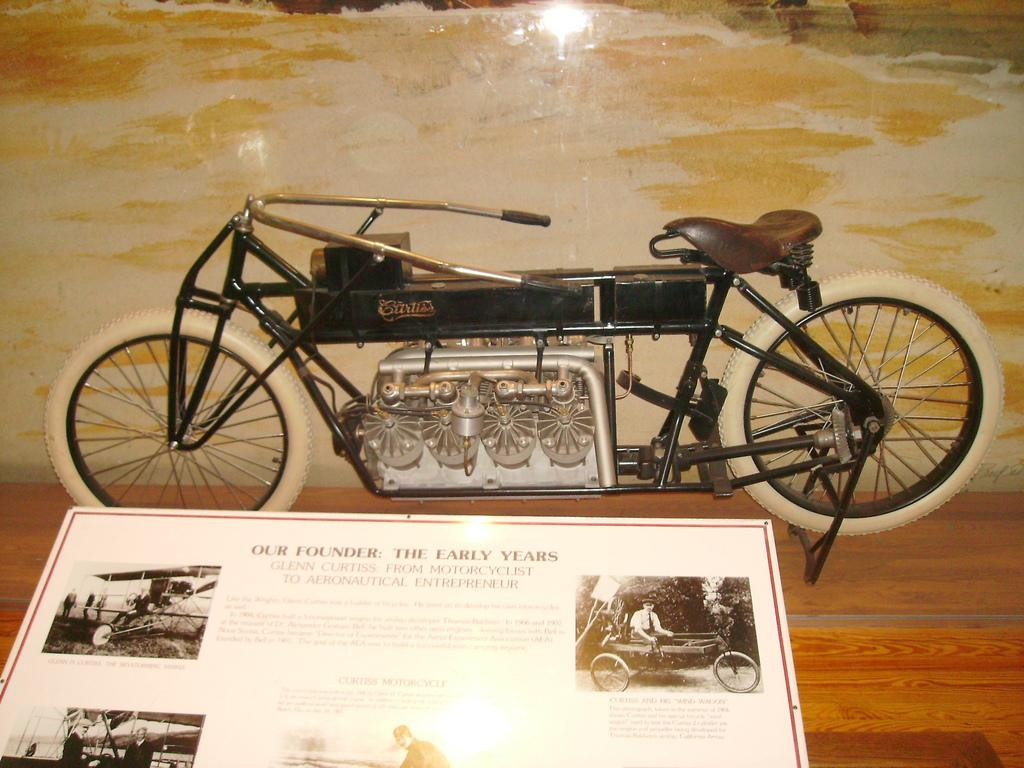What type of toy is on the table in the image? There is a toy bicycle on the table in the image. What else can be seen in the image besides the toy bicycle? There is a board with text and pictures in the image. How many legs does the toy bicycle have in the image? The toy bicycle has two wheels, which are often referred to as "legs" in the context of a bicycle, but in this case, it is a toy bicycle, and the question is not relevant to the image. 